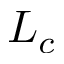Convert formula to latex. <formula><loc_0><loc_0><loc_500><loc_500>L _ { c }</formula> 